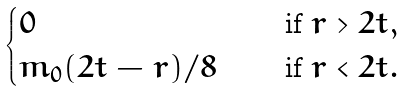Convert formula to latex. <formula><loc_0><loc_0><loc_500><loc_500>\begin{cases} 0 \quad & \text { if } r > 2 t , \\ m _ { 0 } ( 2 t - r ) / 8 \quad & \text { if } r < 2 t . \end{cases}</formula> 